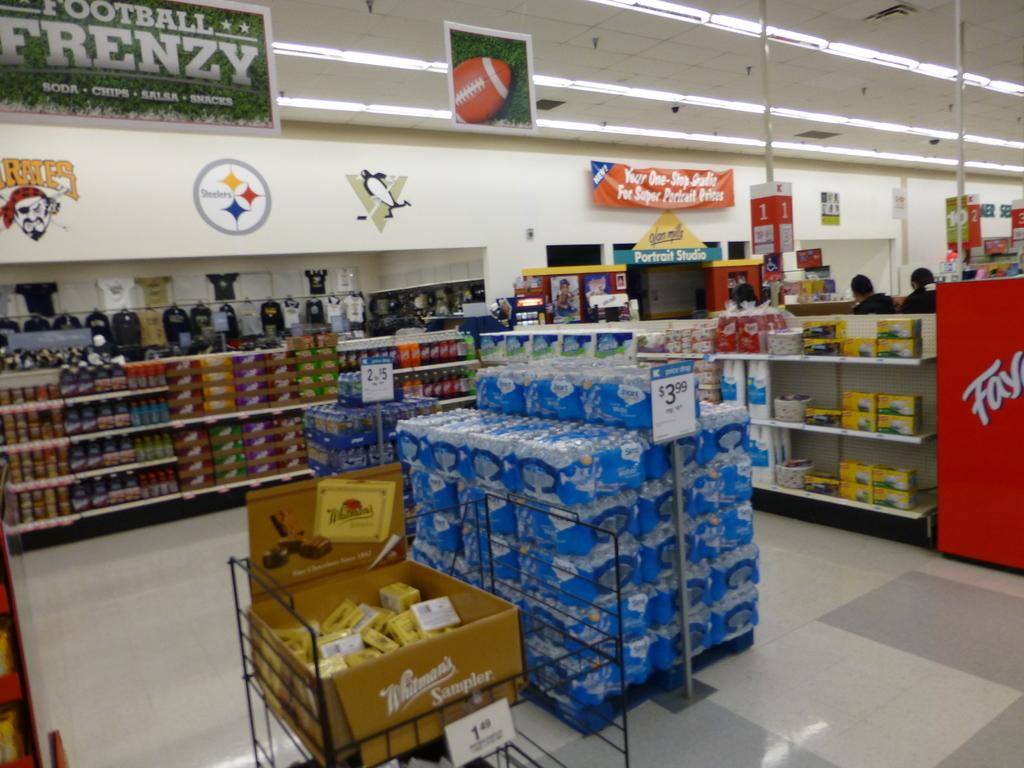What kind of candy is in the gold and yellow box?
Ensure brevity in your answer.  Whitman's. What kind of frenzy?
Provide a succinct answer. Football. 